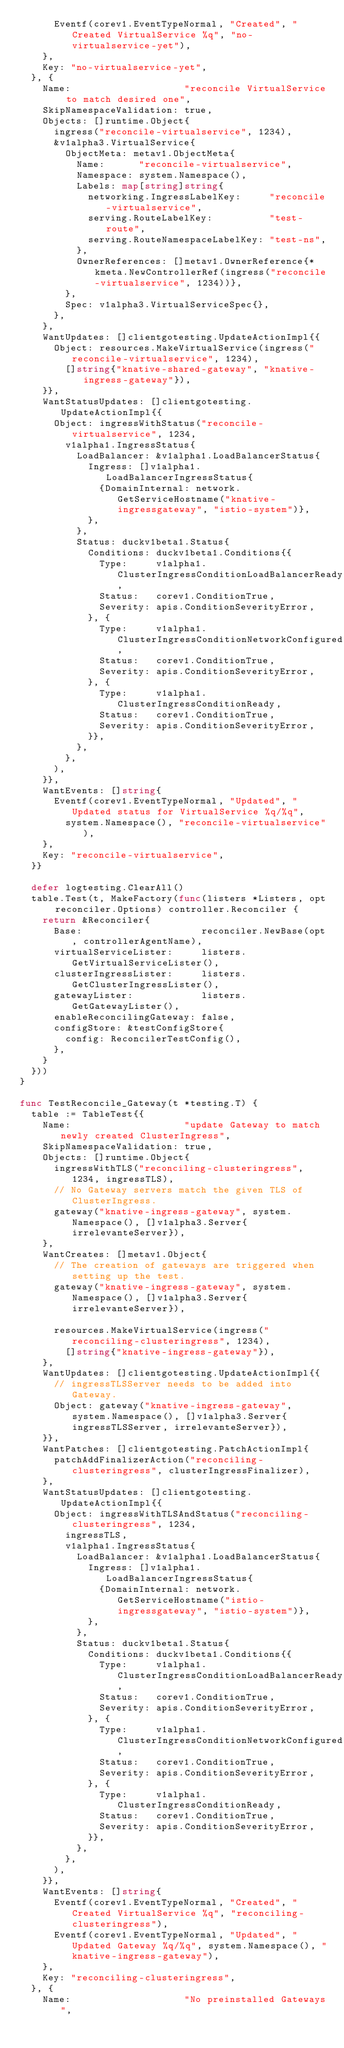Convert code to text. <code><loc_0><loc_0><loc_500><loc_500><_Go_>			Eventf(corev1.EventTypeNormal, "Created", "Created VirtualService %q", "no-virtualservice-yet"),
		},
		Key: "no-virtualservice-yet",
	}, {
		Name:                    "reconcile VirtualService to match desired one",
		SkipNamespaceValidation: true,
		Objects: []runtime.Object{
			ingress("reconcile-virtualservice", 1234),
			&v1alpha3.VirtualService{
				ObjectMeta: metav1.ObjectMeta{
					Name:      "reconcile-virtualservice",
					Namespace: system.Namespace(),
					Labels: map[string]string{
						networking.IngressLabelKey:     "reconcile-virtualservice",
						serving.RouteLabelKey:          "test-route",
						serving.RouteNamespaceLabelKey: "test-ns",
					},
					OwnerReferences: []metav1.OwnerReference{*kmeta.NewControllerRef(ingress("reconcile-virtualservice", 1234))},
				},
				Spec: v1alpha3.VirtualServiceSpec{},
			},
		},
		WantUpdates: []clientgotesting.UpdateActionImpl{{
			Object: resources.MakeVirtualService(ingress("reconcile-virtualservice", 1234),
				[]string{"knative-shared-gateway", "knative-ingress-gateway"}),
		}},
		WantStatusUpdates: []clientgotesting.UpdateActionImpl{{
			Object: ingressWithStatus("reconcile-virtualservice", 1234,
				v1alpha1.IngressStatus{
					LoadBalancer: &v1alpha1.LoadBalancerStatus{
						Ingress: []v1alpha1.LoadBalancerIngressStatus{
							{DomainInternal: network.GetServiceHostname("knative-ingressgateway", "istio-system")},
						},
					},
					Status: duckv1beta1.Status{
						Conditions: duckv1beta1.Conditions{{
							Type:     v1alpha1.ClusterIngressConditionLoadBalancerReady,
							Status:   corev1.ConditionTrue,
							Severity: apis.ConditionSeverityError,
						}, {
							Type:     v1alpha1.ClusterIngressConditionNetworkConfigured,
							Status:   corev1.ConditionTrue,
							Severity: apis.ConditionSeverityError,
						}, {
							Type:     v1alpha1.ClusterIngressConditionReady,
							Status:   corev1.ConditionTrue,
							Severity: apis.ConditionSeverityError,
						}},
					},
				},
			),
		}},
		WantEvents: []string{
			Eventf(corev1.EventTypeNormal, "Updated", "Updated status for VirtualService %q/%q",
				system.Namespace(), "reconcile-virtualservice"),
		},
		Key: "reconcile-virtualservice",
	}}

	defer logtesting.ClearAll()
	table.Test(t, MakeFactory(func(listers *Listers, opt reconciler.Options) controller.Reconciler {
		return &Reconciler{
			Base:                     reconciler.NewBase(opt, controllerAgentName),
			virtualServiceLister:     listers.GetVirtualServiceLister(),
			clusterIngressLister:     listers.GetClusterIngressLister(),
			gatewayLister:            listers.GetGatewayLister(),
			enableReconcilingGateway: false,
			configStore: &testConfigStore{
				config: ReconcilerTestConfig(),
			},
		}
	}))
}

func TestReconcile_Gateway(t *testing.T) {
	table := TableTest{{
		Name:                    "update Gateway to match newly created ClusterIngress",
		SkipNamespaceValidation: true,
		Objects: []runtime.Object{
			ingressWithTLS("reconciling-clusteringress", 1234, ingressTLS),
			// No Gateway servers match the given TLS of ClusterIngress.
			gateway("knative-ingress-gateway", system.Namespace(), []v1alpha3.Server{irrelevanteServer}),
		},
		WantCreates: []metav1.Object{
			// The creation of gateways are triggered when setting up the test.
			gateway("knative-ingress-gateway", system.Namespace(), []v1alpha3.Server{irrelevanteServer}),

			resources.MakeVirtualService(ingress("reconciling-clusteringress", 1234),
				[]string{"knative-ingress-gateway"}),
		},
		WantUpdates: []clientgotesting.UpdateActionImpl{{
			// ingressTLSServer needs to be added into Gateway.
			Object: gateway("knative-ingress-gateway", system.Namespace(), []v1alpha3.Server{ingressTLSServer, irrelevanteServer}),
		}},
		WantPatches: []clientgotesting.PatchActionImpl{
			patchAddFinalizerAction("reconciling-clusteringress", clusterIngressFinalizer),
		},
		WantStatusUpdates: []clientgotesting.UpdateActionImpl{{
			Object: ingressWithTLSAndStatus("reconciling-clusteringress", 1234,
				ingressTLS,
				v1alpha1.IngressStatus{
					LoadBalancer: &v1alpha1.LoadBalancerStatus{
						Ingress: []v1alpha1.LoadBalancerIngressStatus{
							{DomainInternal: network.GetServiceHostname("istio-ingressgateway", "istio-system")},
						},
					},
					Status: duckv1beta1.Status{
						Conditions: duckv1beta1.Conditions{{
							Type:     v1alpha1.ClusterIngressConditionLoadBalancerReady,
							Status:   corev1.ConditionTrue,
							Severity: apis.ConditionSeverityError,
						}, {
							Type:     v1alpha1.ClusterIngressConditionNetworkConfigured,
							Status:   corev1.ConditionTrue,
							Severity: apis.ConditionSeverityError,
						}, {
							Type:     v1alpha1.ClusterIngressConditionReady,
							Status:   corev1.ConditionTrue,
							Severity: apis.ConditionSeverityError,
						}},
					},
				},
			),
		}},
		WantEvents: []string{
			Eventf(corev1.EventTypeNormal, "Created", "Created VirtualService %q", "reconciling-clusteringress"),
			Eventf(corev1.EventTypeNormal, "Updated", "Updated Gateway %q/%q", system.Namespace(), "knative-ingress-gateway"),
		},
		Key: "reconciling-clusteringress",
	}, {
		Name:                    "No preinstalled Gateways",</code> 